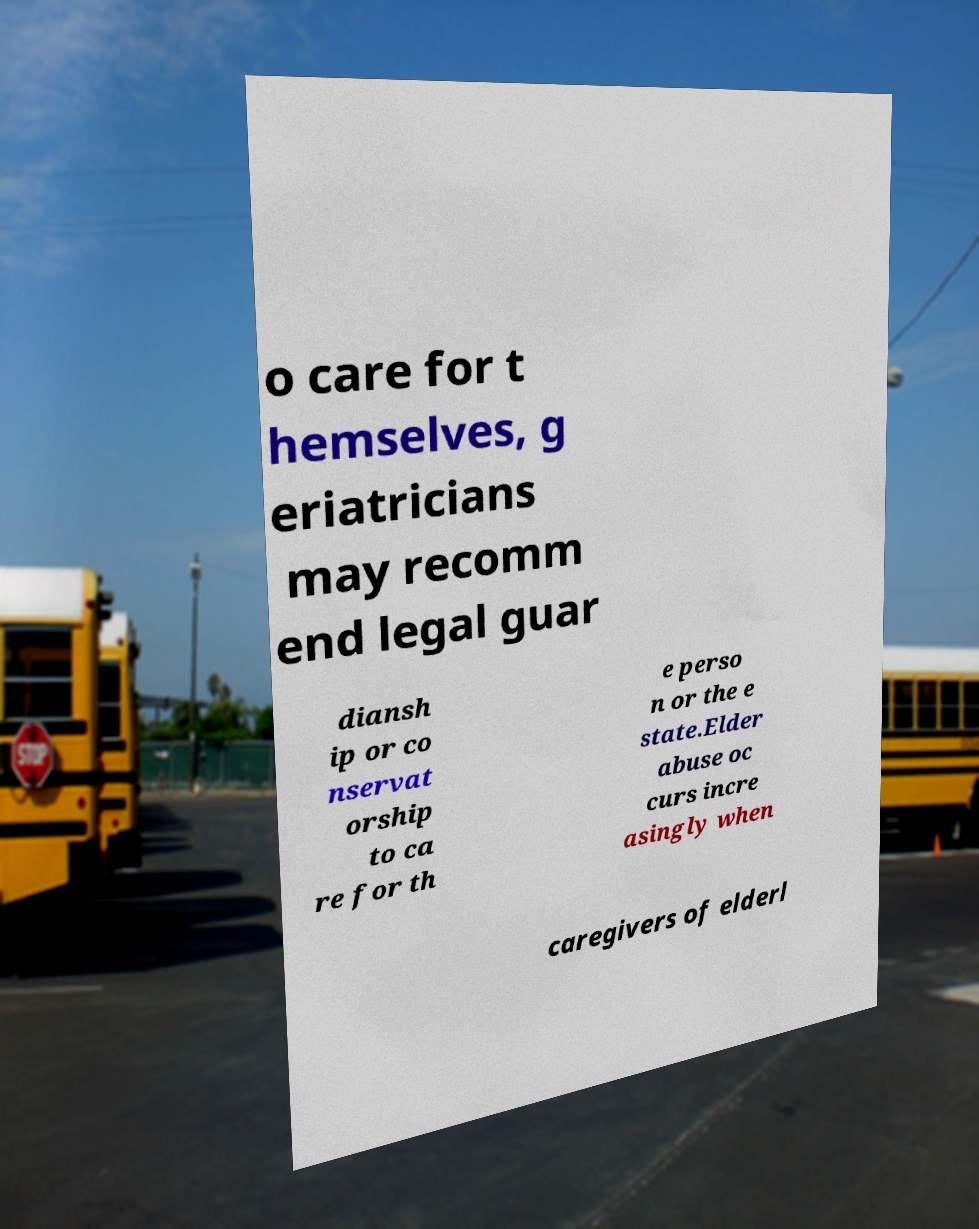I need the written content from this picture converted into text. Can you do that? o care for t hemselves, g eriatricians may recomm end legal guar diansh ip or co nservat orship to ca re for th e perso n or the e state.Elder abuse oc curs incre asingly when caregivers of elderl 